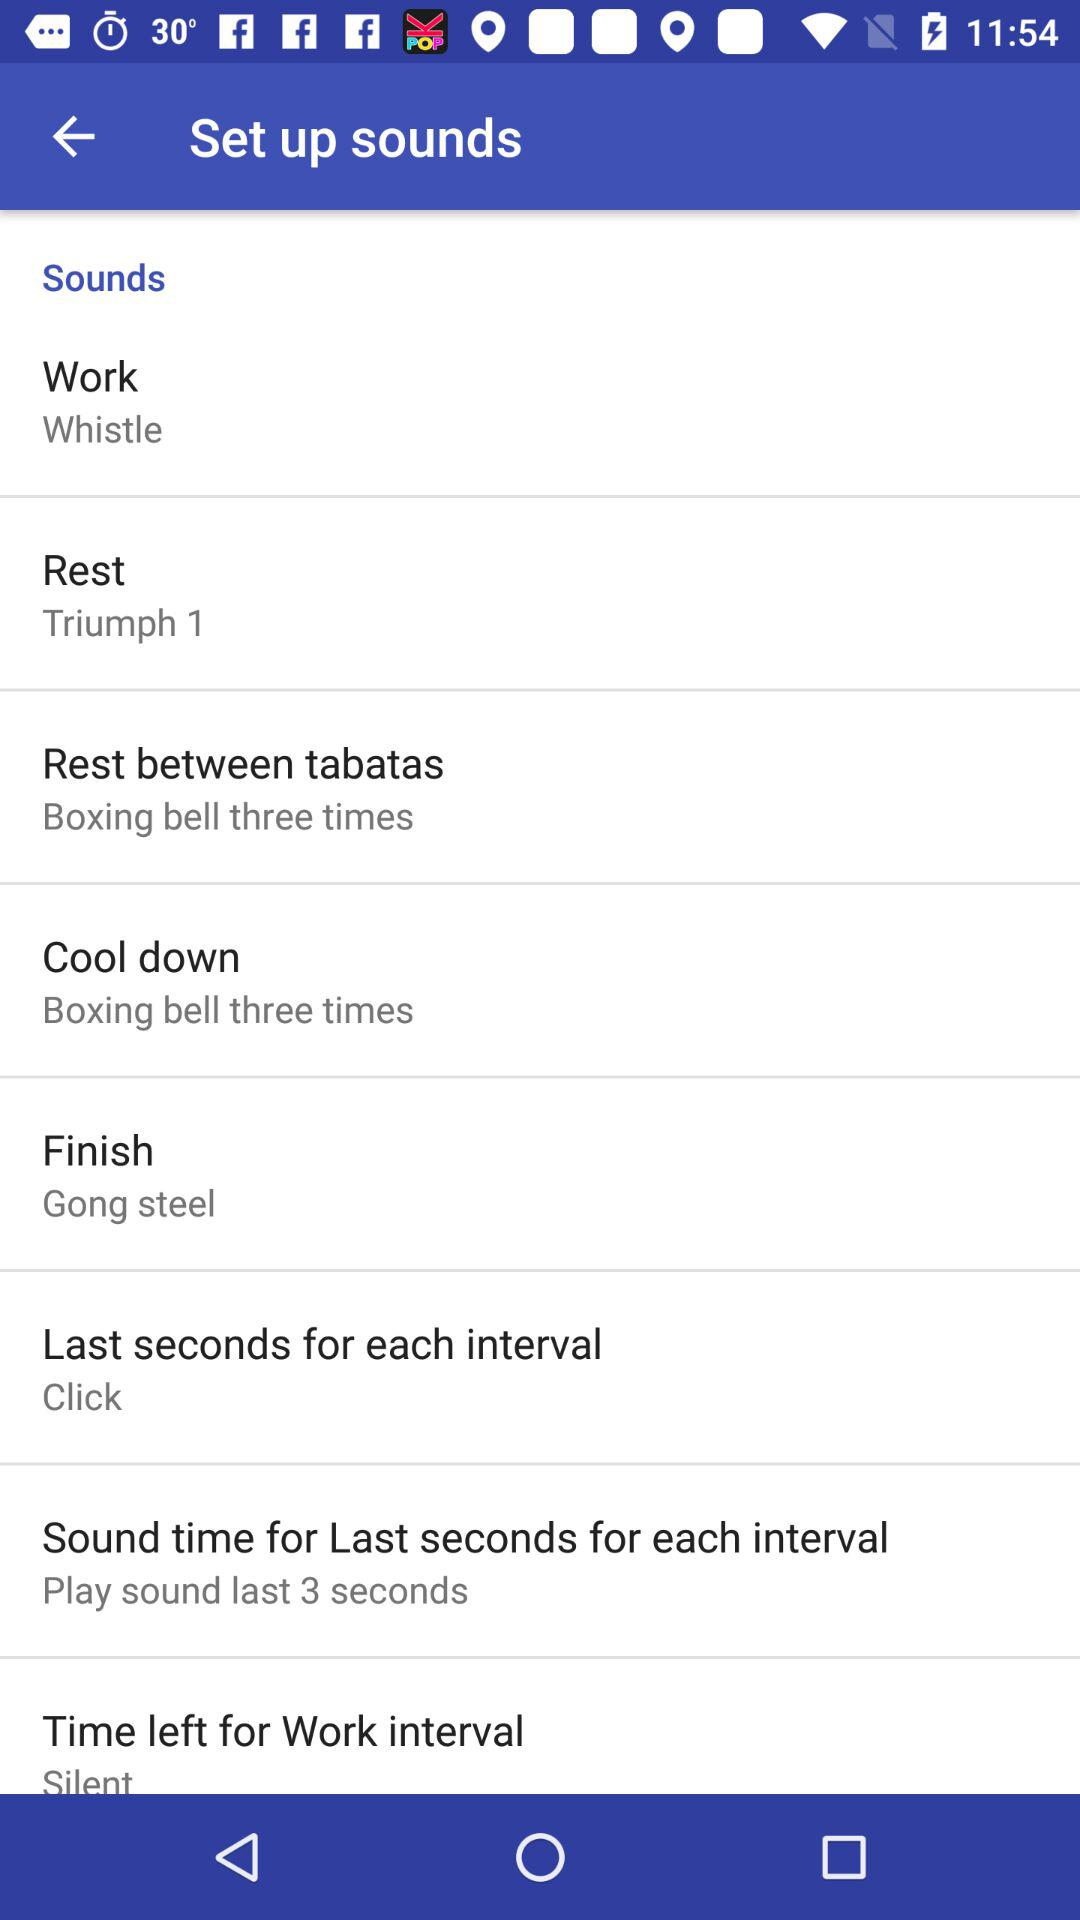How many sounds are not silent?
Answer the question using a single word or phrase. 5 